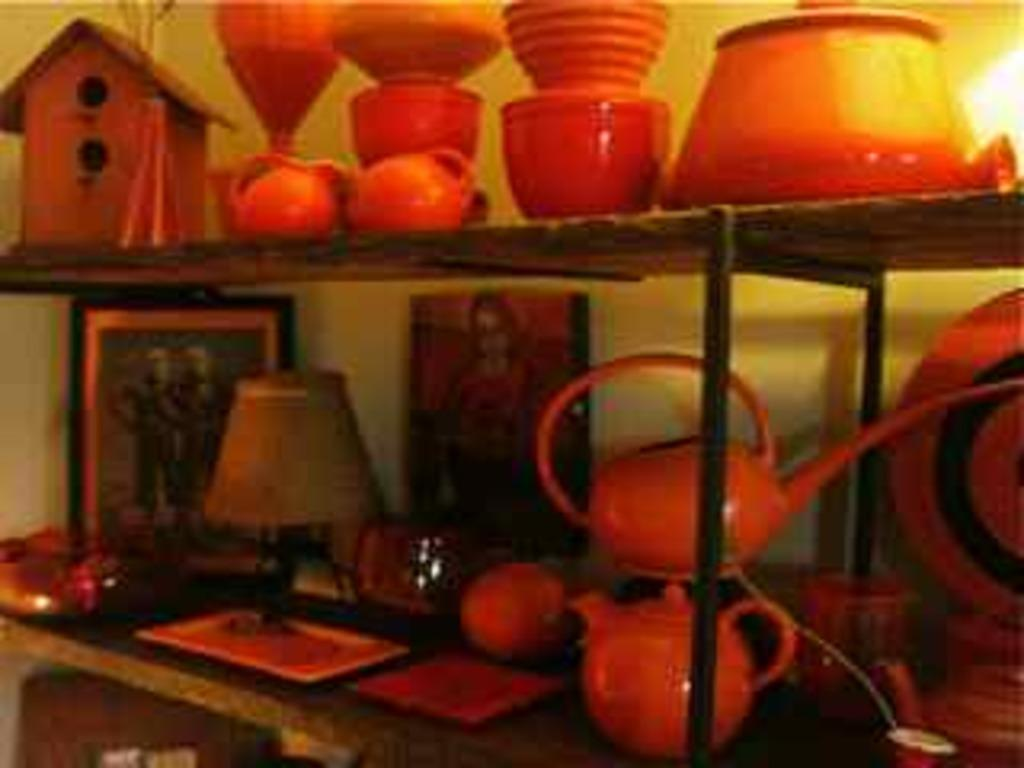What type of furniture is visible in the image? There are shelves in the image. What items can be seen on the shelves? Teapots, lamps, cups, mugs, pots, and other objects are present on the shelves. What is hanging on the wall in the image? A painting is present in the image. What type of structure is visible in the image? There is a hut in the image. How many clovers are scattered around the hut in the image? There are no clovers present in the image. What type of holiday is being celebrated in the image? There is no indication of a holiday being celebrated in the image. How many kittens are playing on the shelves in the image? There are no kittens present in the image. 